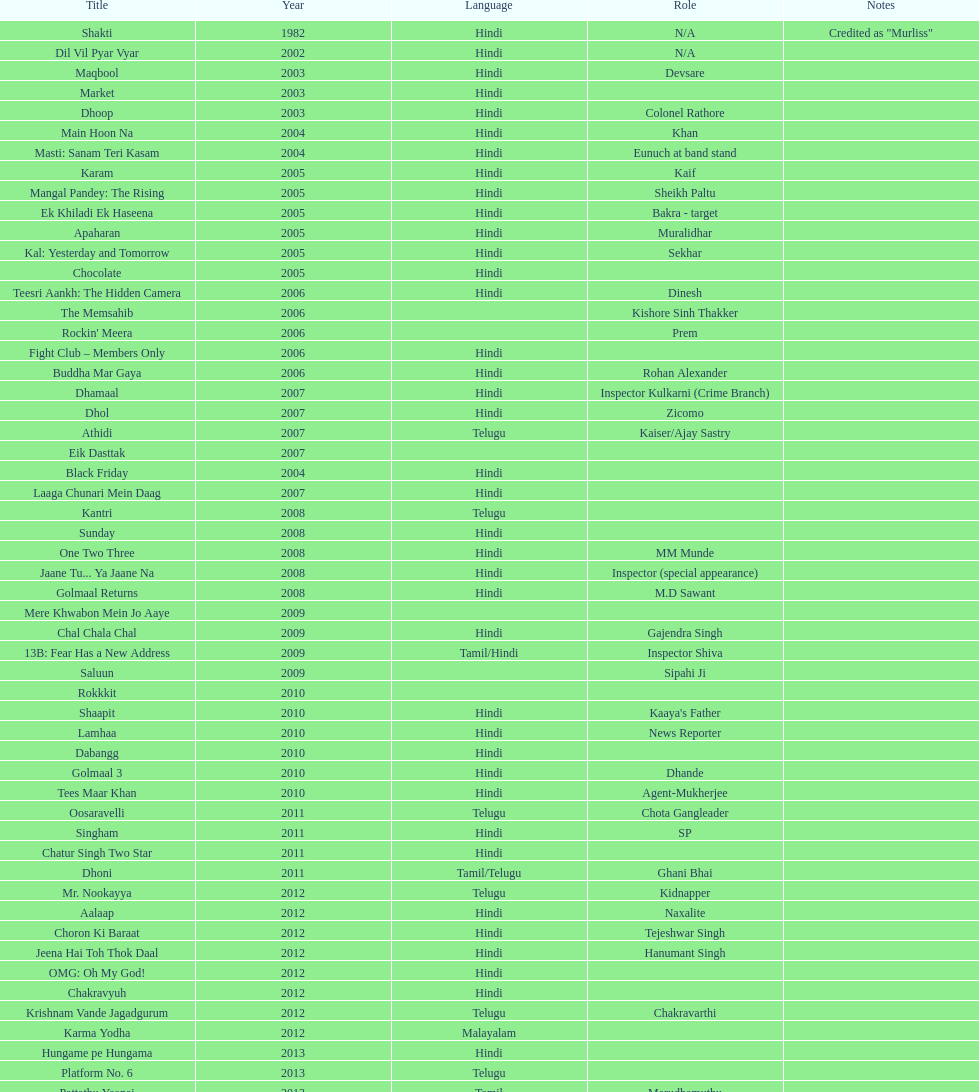Does maqbool have longer notes than shakti? No. 